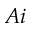<formula> <loc_0><loc_0><loc_500><loc_500>A i</formula> 